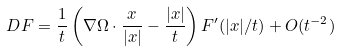Convert formula to latex. <formula><loc_0><loc_0><loc_500><loc_500>D F = \frac { 1 } { t } \left ( \nabla \Omega \cdot \frac { x } { | x | } - \frac { | x | } { t } \right ) F ^ { \prime } ( | x | / t ) + O ( t ^ { - 2 } )</formula> 